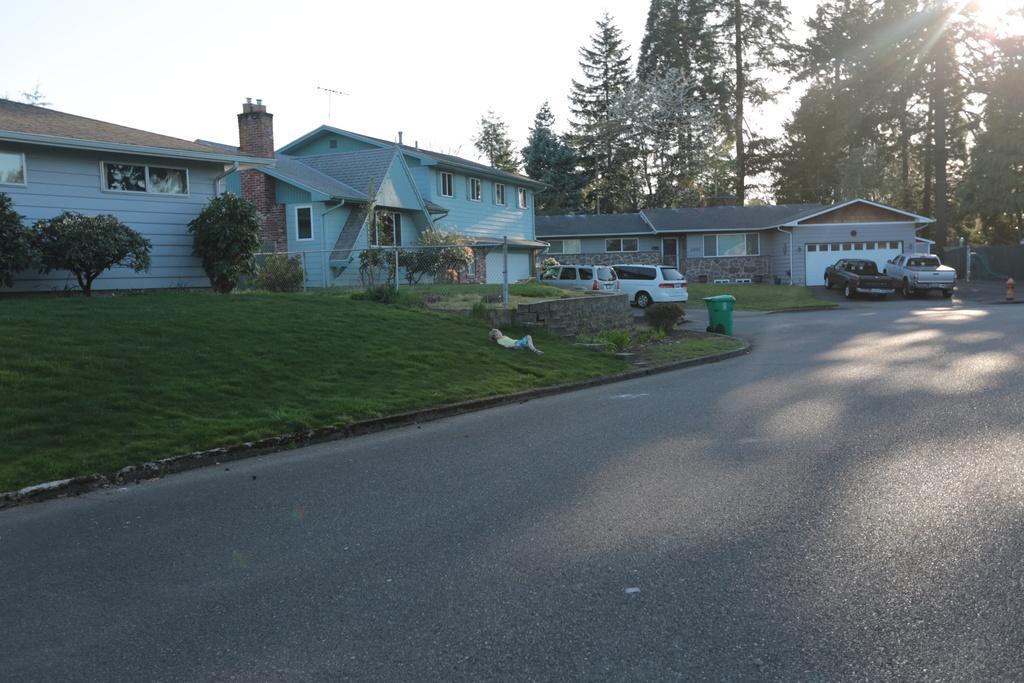Could you give a brief overview of what you see in this image? In this image we can see houses. In front of the houses grassy land, plants, cars and road is present. Background of the image trees are there. 